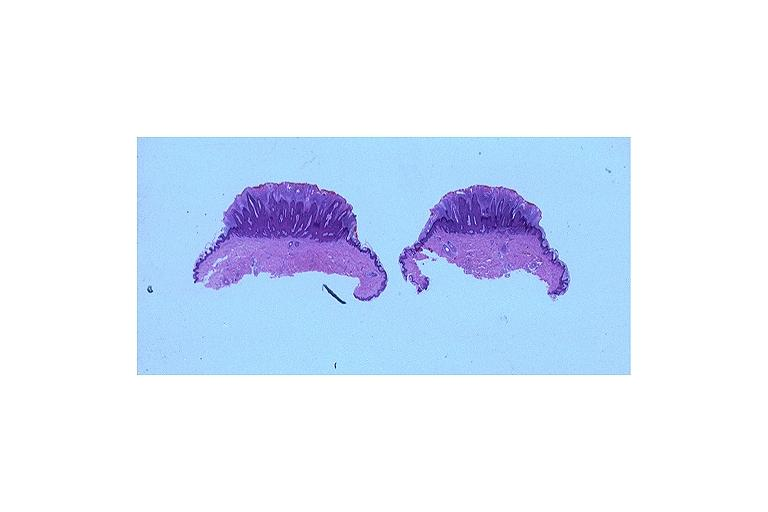does cranial artery show verruca vulgaris?
Answer the question using a single word or phrase. No 